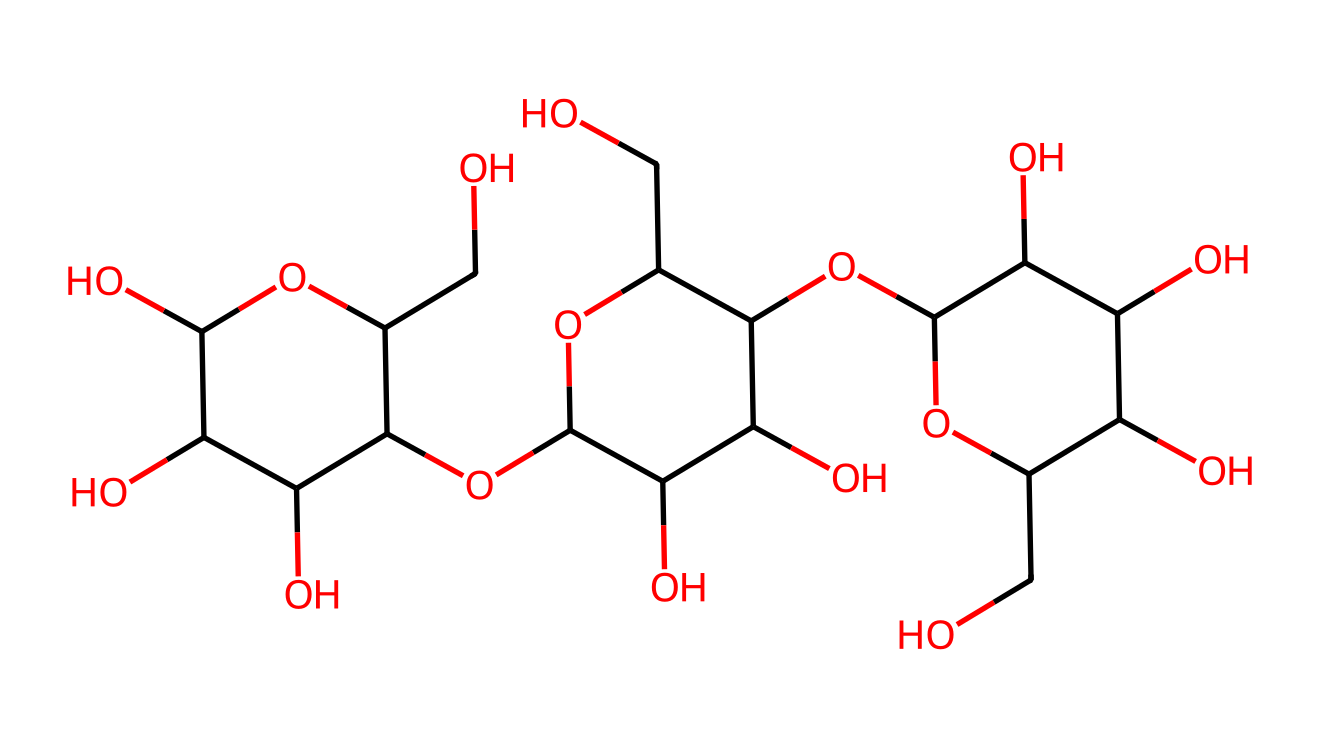What is the molecular formula of this chemical? To determine the molecular formula, we can analyze the SMILES representation for its constituent elements. By counting the occurrences of each atom type (carbons, oxygens, and hydrogens), we can establish the molecular formula. The total number of carbon (C) atoms is 18, hydrogen (H) atoms is 30, and oxygen (O) atoms is 9, leading to the formula C18H30O9.
Answer: C18H30O9 How many chiral centers are present in this molecule? A chiral center typically has four different substituents attached to a carbon atom. By examining the structure indicated by the SMILES notation, we can identify carbon atoms that meet this criterion. This molecule contains 5 chiral centers, specifically at certain carbons in the repeating units of glucose.
Answer: 5 What type of chemical is cellulose classified as? Cellulose is classified based on its solubility characteristics. It does not dissociate into ions in solution; hence, it is categorized as a non-electrolyte.
Answer: non-electrolyte Which components result in the high tensile strength of bamboo? The high tensile strength of bamboo is primarily due to the presence of cellulose, which provides structural support. The long chains of the cellulose polymer create strong interactions between the chains, enhancing strength. These interactions help prevent breakage under tension.
Answer: cellulose What is the primary functional group in this structure? The primary functional groups in cellulose are hydroxyl groups, -OH, which are prevalent throughout the structural representation of the chemical. The presence of these groups contributes to cellulose's solubility in water and reactivity.
Answer: hydroxyl groups How does the presence of hydrogen bonding affect this molecule? Hydrogen bonding occurs between hydroxyl groups in cellulose, increasing intermolecular forces and resulting in a solid, rigid structure. This structural integrity is critical for the use of bamboo as a construction material, as it provides strength and stability.
Answer: rigidity 